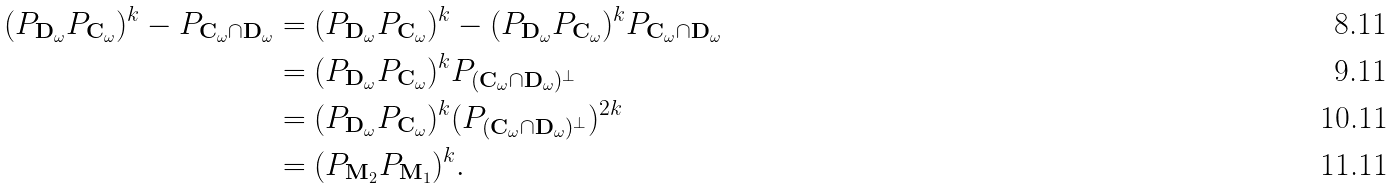<formula> <loc_0><loc_0><loc_500><loc_500>( P _ { \mathbf D _ { \omega } } P _ { \mathbf C _ { \omega } } ) ^ { k } - P _ { \mathbf C _ { \omega } \cap \mathbf D _ { \omega } } & = ( P _ { \mathbf D _ { \omega } } P _ { \mathbf C _ { \omega } } ) ^ { k } - ( P _ { \mathbf D _ { \omega } } P _ { \mathbf C _ { \omega } } ) ^ { k } P _ { \mathbf C _ { \omega } \cap \mathbf D _ { \omega } } \\ & = ( P _ { \mathbf D _ { \omega } } P _ { \mathbf C _ { \omega } } ) ^ { k } P _ { ( \mathbf C _ { \omega } \cap \mathbf D _ { \omega } ) ^ { \perp } } \\ & = ( P _ { \mathbf D _ { \omega } } P _ { \mathbf C _ { \omega } } ) ^ { k } ( P _ { ( \mathbf C _ { \omega } \cap \mathbf D _ { \omega } ) ^ { \perp } } ) ^ { 2 k } \\ & = ( P _ { \mathbf M _ { 2 } } P _ { \mathbf M _ { 1 } } ) ^ { k } .</formula> 